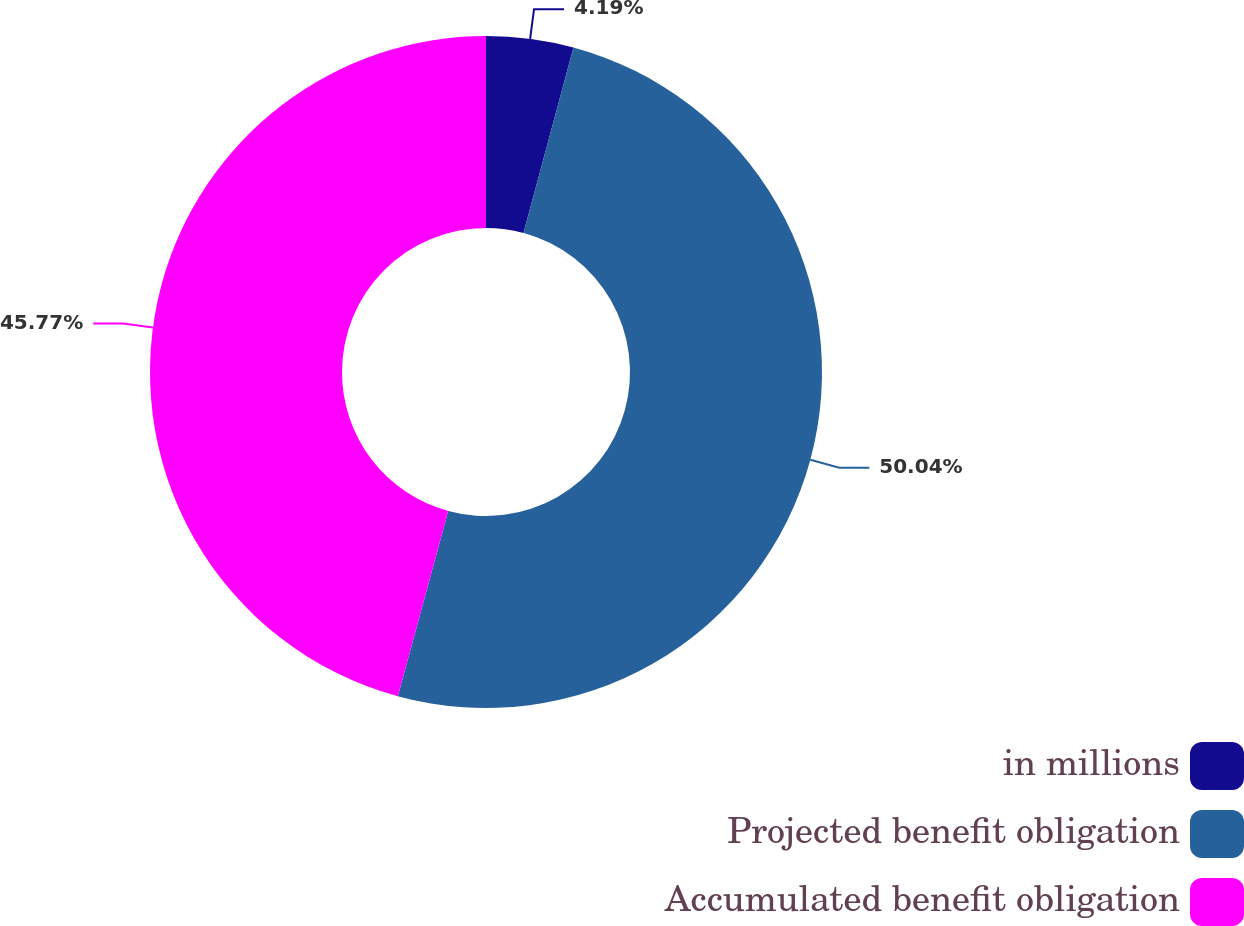Convert chart to OTSL. <chart><loc_0><loc_0><loc_500><loc_500><pie_chart><fcel>in millions<fcel>Projected benefit obligation<fcel>Accumulated benefit obligation<nl><fcel>4.19%<fcel>50.03%<fcel>45.77%<nl></chart> 